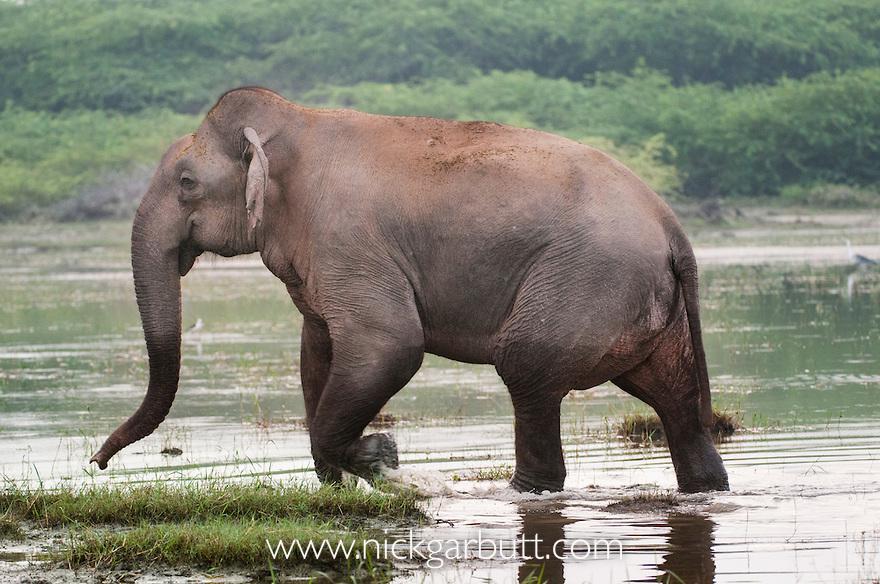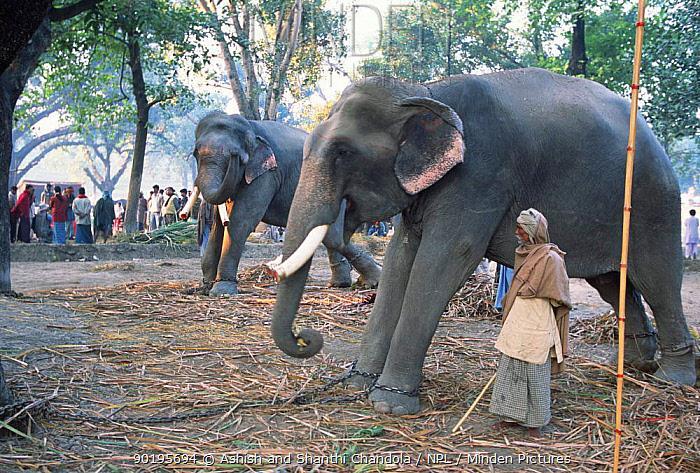The first image is the image on the left, the second image is the image on the right. For the images shown, is this caption "An elephant is in profile facing the right." true? Answer yes or no. No. The first image is the image on the left, the second image is the image on the right. Examine the images to the left and right. Is the description "Each picture has only one elephant in it." accurate? Answer yes or no. No. 